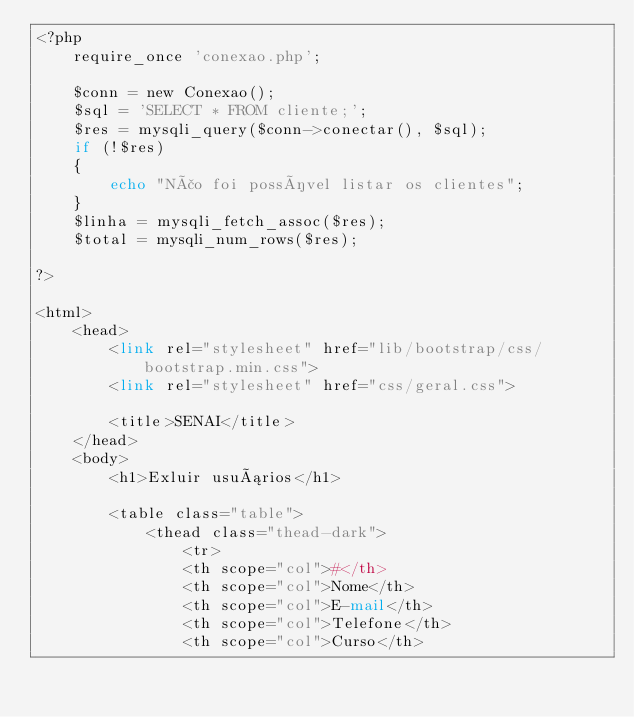<code> <loc_0><loc_0><loc_500><loc_500><_PHP_><?php
    require_once 'conexao.php';

    $conn = new Conexao();
    $sql = 'SELECT * FROM cliente;';
    $res = mysqli_query($conn->conectar(), $sql);
    if (!$res)    
    {
        echo "Não foi possível listar os clientes";
    }
    $linha = mysqli_fetch_assoc($res);
    $total = mysqli_num_rows($res);

?>

<html>
    <head>
        <link rel="stylesheet" href="lib/bootstrap/css/bootstrap.min.css">
        <link rel="stylesheet" href="css/geral.css">
                
        <title>SENAI</title>
    </head>
    <body>
        <h1>Exluir usuários</h1>

        <table class="table">
            <thead class="thead-dark">
                <tr>
                <th scope="col">#</th>
                <th scope="col">Nome</th>
                <th scope="col">E-mail</th>
                <th scope="col">Telefone</th>
                <th scope="col">Curso</th></code> 